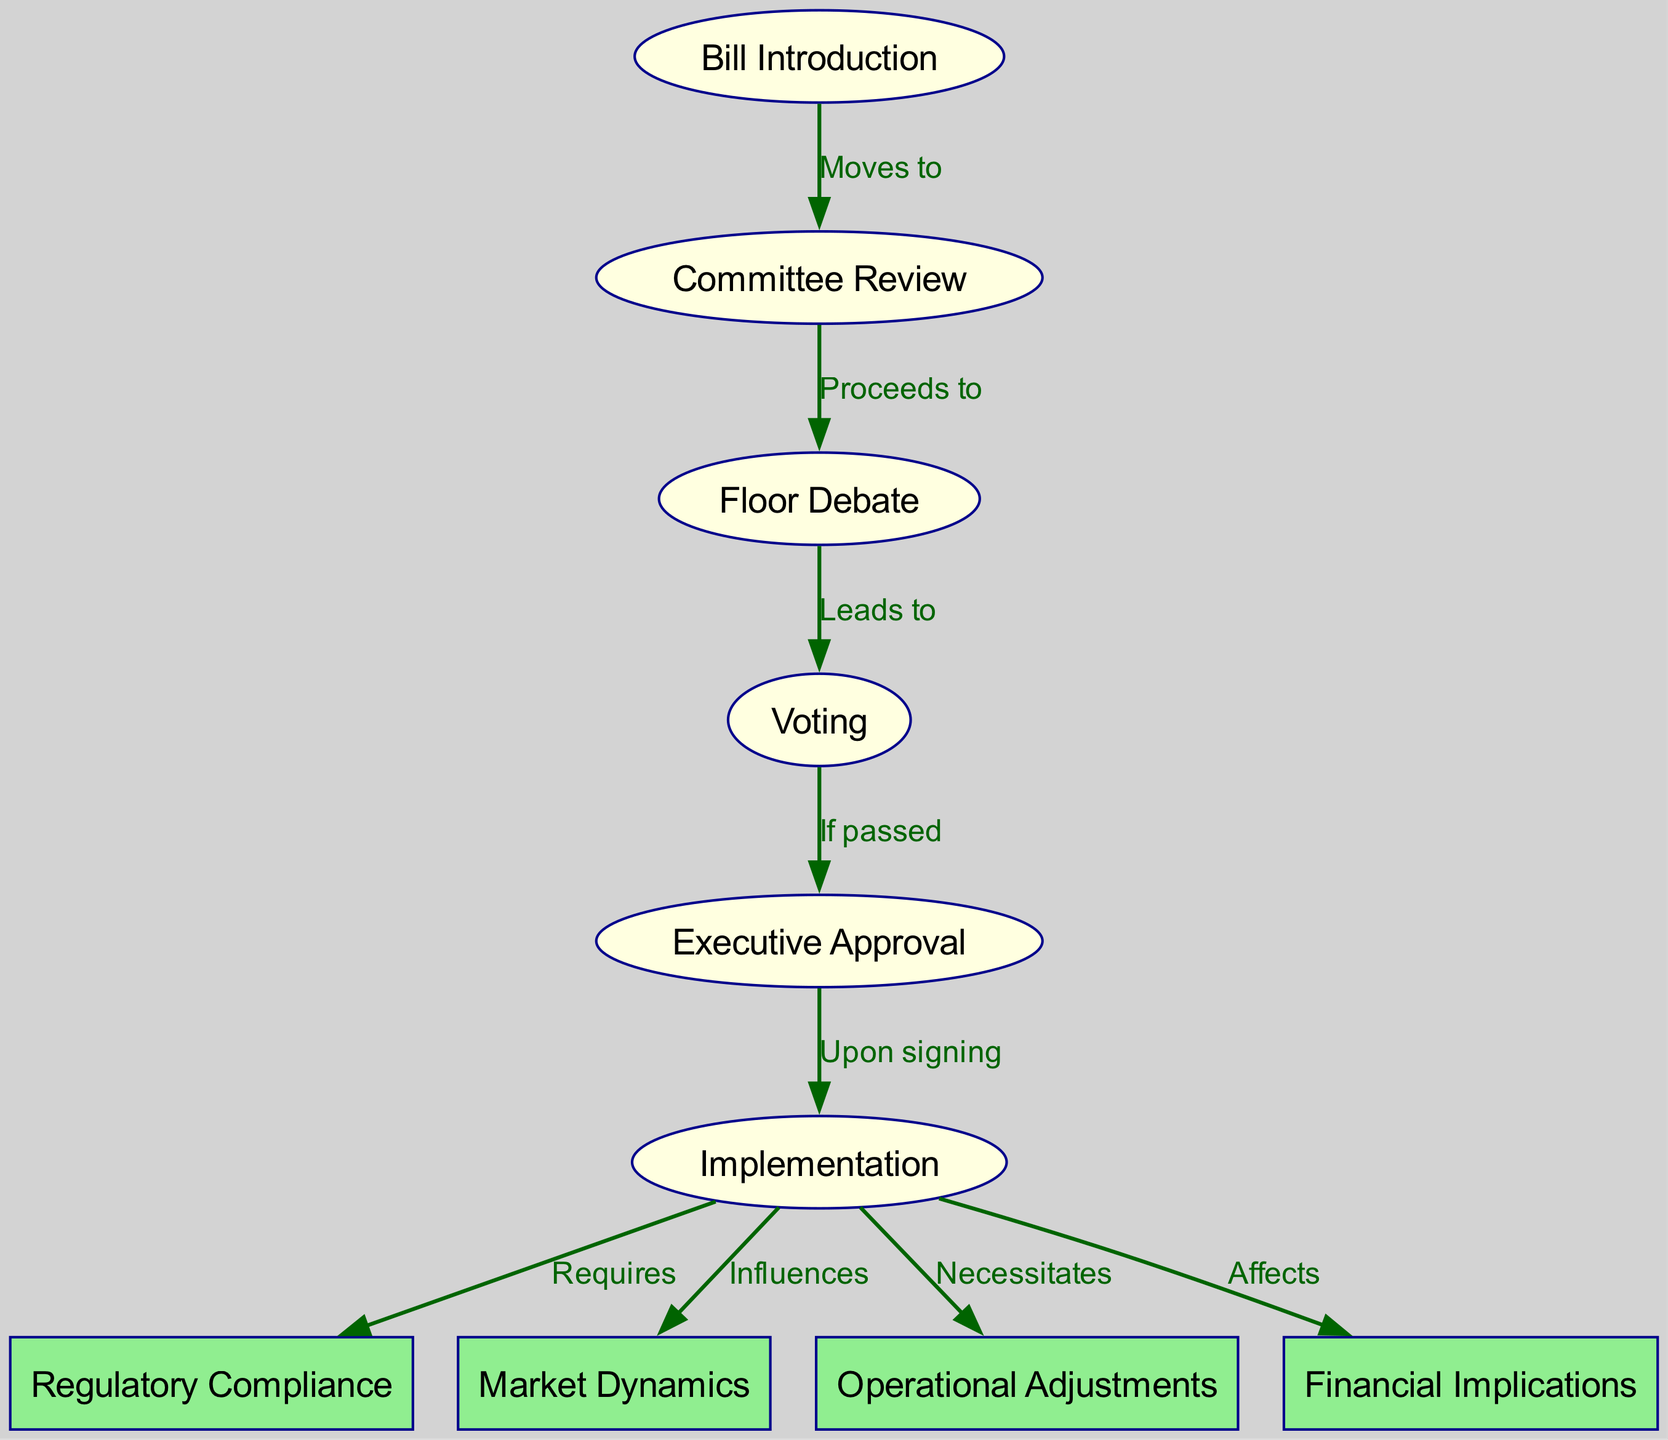What is the first stage in the lifecycle of a proposed legislation? The first stage is indicated by the node labeled "Bill Introduction." This is the starting point of the legislative process.
Answer: Bill Introduction How many edges are there in the diagram? By counting the connections between the nodes, there are a total of 9 edges that represent the flow between different stages of the legislative process.
Answer: 9 What happens after "Committee Review"? The diagram shows that after "Committee Review," the process "Proceeds to" the node labeled "Floor Debate." This indicates the next step in the lifecycle of the legislation.
Answer: Floor Debate What does "Executive Approval" lead to? According to the diagram, “Executive Approval” is linked to the next step in the process, which is the node labeled "Implementation," indicating what follows after signing the bill.
Answer: Implementation How does the proposed legislation influence "Market Dynamics"? The diagram illustrates that "Implementation" directly influences "Market Dynamics," showing the impact the new legislation may have on market behavior post-implementation.
Answer: Influences What is required after "Implementation"? The node labeled "Regulatory Compliance" is marked as what is needed following "Implementation" in the diagram, signifying compliance requirements that must be met.
Answer: Requires What label connects "Floor Debate" to "Voting"? The edge between "Floor Debate" and "Voting" is labeled "Leads to," indicating that after debate, the next action is to vote on the legislation.
Answer: Leads to Which step indicates if the bill passes or not? The diagram highlights that "Voting" determines if the proposed legislation gets passed, leading to "Executive Approval" if successful.
Answer: Voting What is the relationship between "Implementation" and "Operational Adjustments"? The diagram depicts that "Implementation" "Necessitates" "Operational Adjustments," meaning that implementing the legislation will require changes in operations.
Answer: Necessitates 